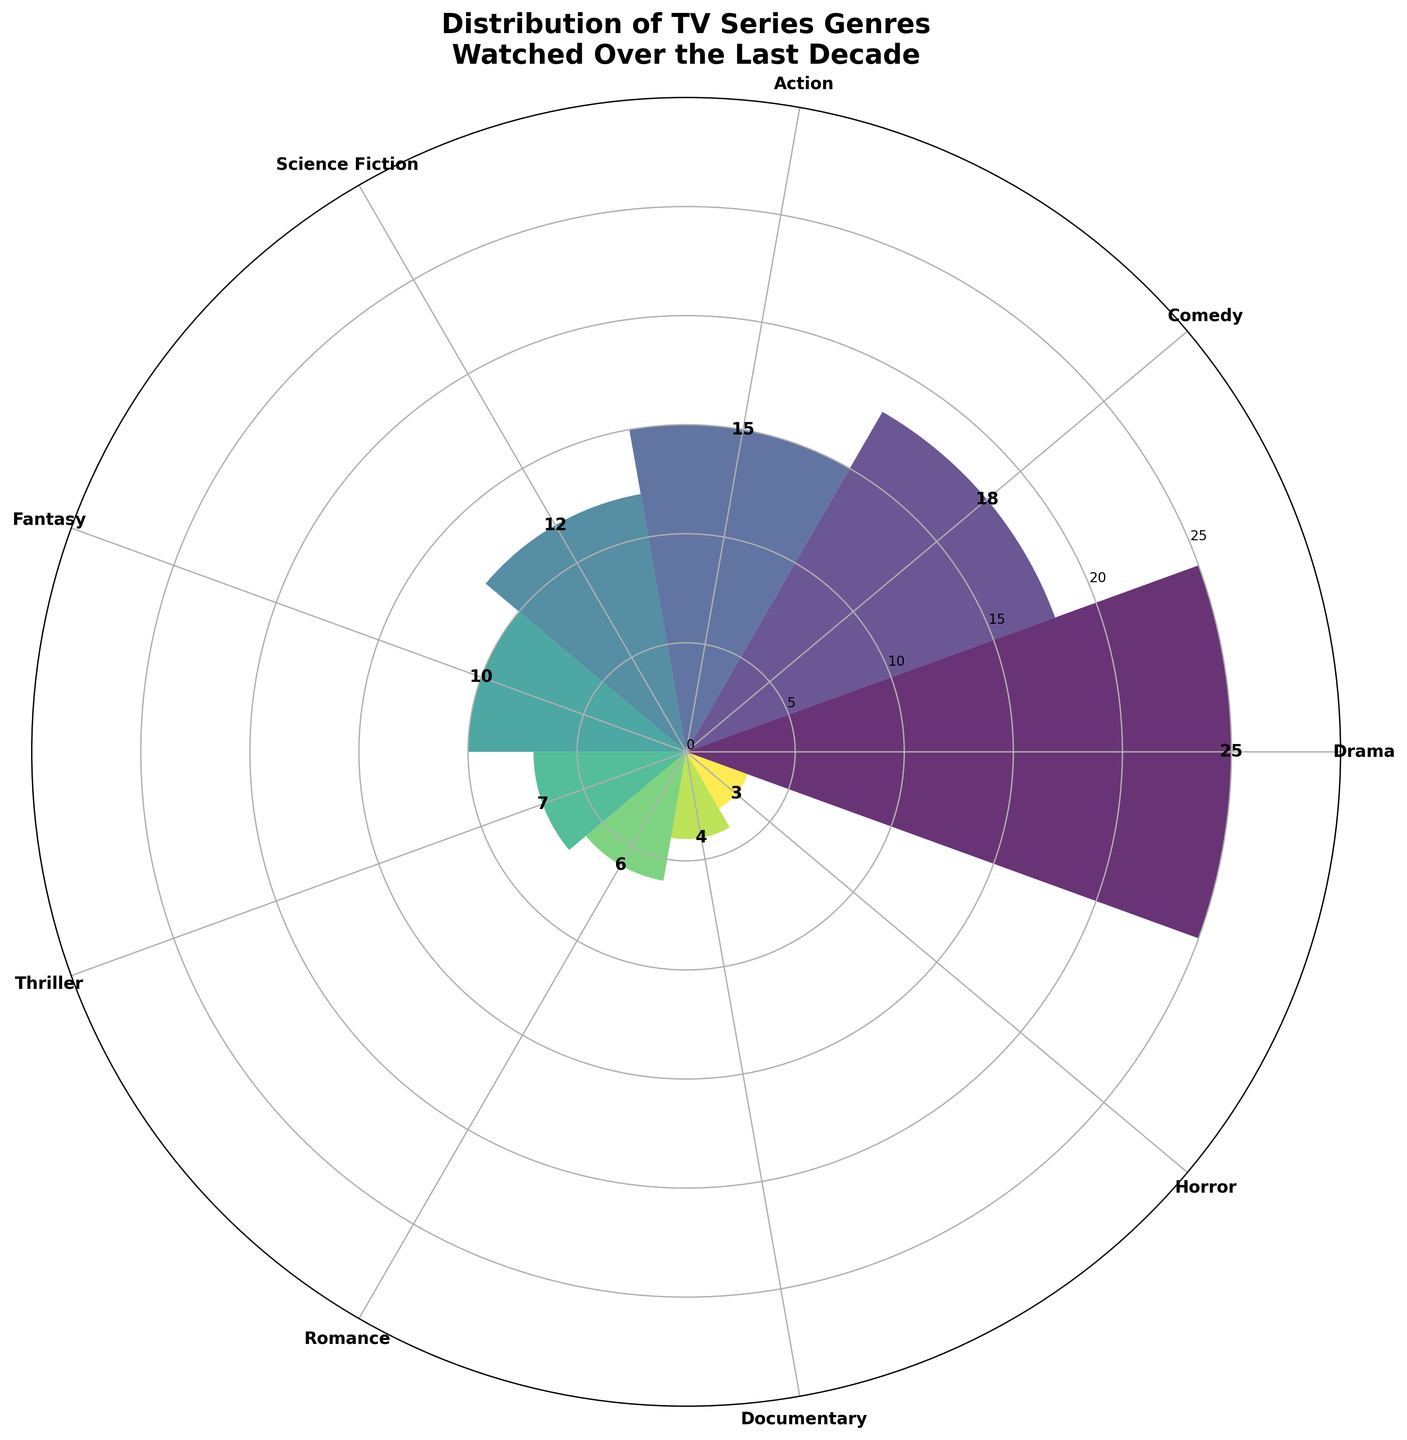What is the title of the chart? Read the information from the top of the chart where the title is located.
Answer: Distribution of TV Series Genres Watched Over the Last Decade Which genre has the highest number of TV series watched? Identify the genre with the longest bar in the polar area chart.
Answer: Drama What is the total number of TV series watched across all genres? Sum the number of TV series for all genres listed in the chart. 25 (Drama) + 18 (Comedy) + 15 (Action) + 12 (Science Fiction) + 10 (Fantasy) + 7 (Thriller) + 6 (Romance) + 4 (Documentary) + 3 (Horror) = 100
Answer: 100 Which genre has fewer TV series watched, Horror or Science Fiction? Compare the heights of the bars for Horror and Science Fiction; Horror has 3 and Science Fiction has 12.
Answer: Horror How many more TV series were watched in Comedy than in Documentary? Subtract the number of TV series for Documentary from the number for Comedy. 18 (Comedy) - 4 (Documentary) = 14
Answer: 14 What is the sum of the number of TV series watched for Fantasy and Thriller? Add the number of TV series for Fantasy and Thriller. 10 (Fantasy) + 7 (Thriller) = 17
Answer: 17 Which genres have exactly 10 or more TV series watched? Check the bars with values that are 10 or greater. Drama (25), Comedy (18), Action (15), Science Fiction (12), Fantasy (10).
Answer: Drama, Comedy, Action, Science Fiction, Fantasy What is the ratio of the number of TV series watched in Action to those watched in Thriller? Divide the number of TV series for Action by the number for Thriller. 15 (Action) / 7 (Thriller) ≈ 2.14
Answer: 2.14 How many genres have fewer than 10 TV series watched? Count the bars where the number of TV series is less than 10. Thriller (7), Romance (6), Documentary (4), Horror (3) = 4 genres
Answer: 4 